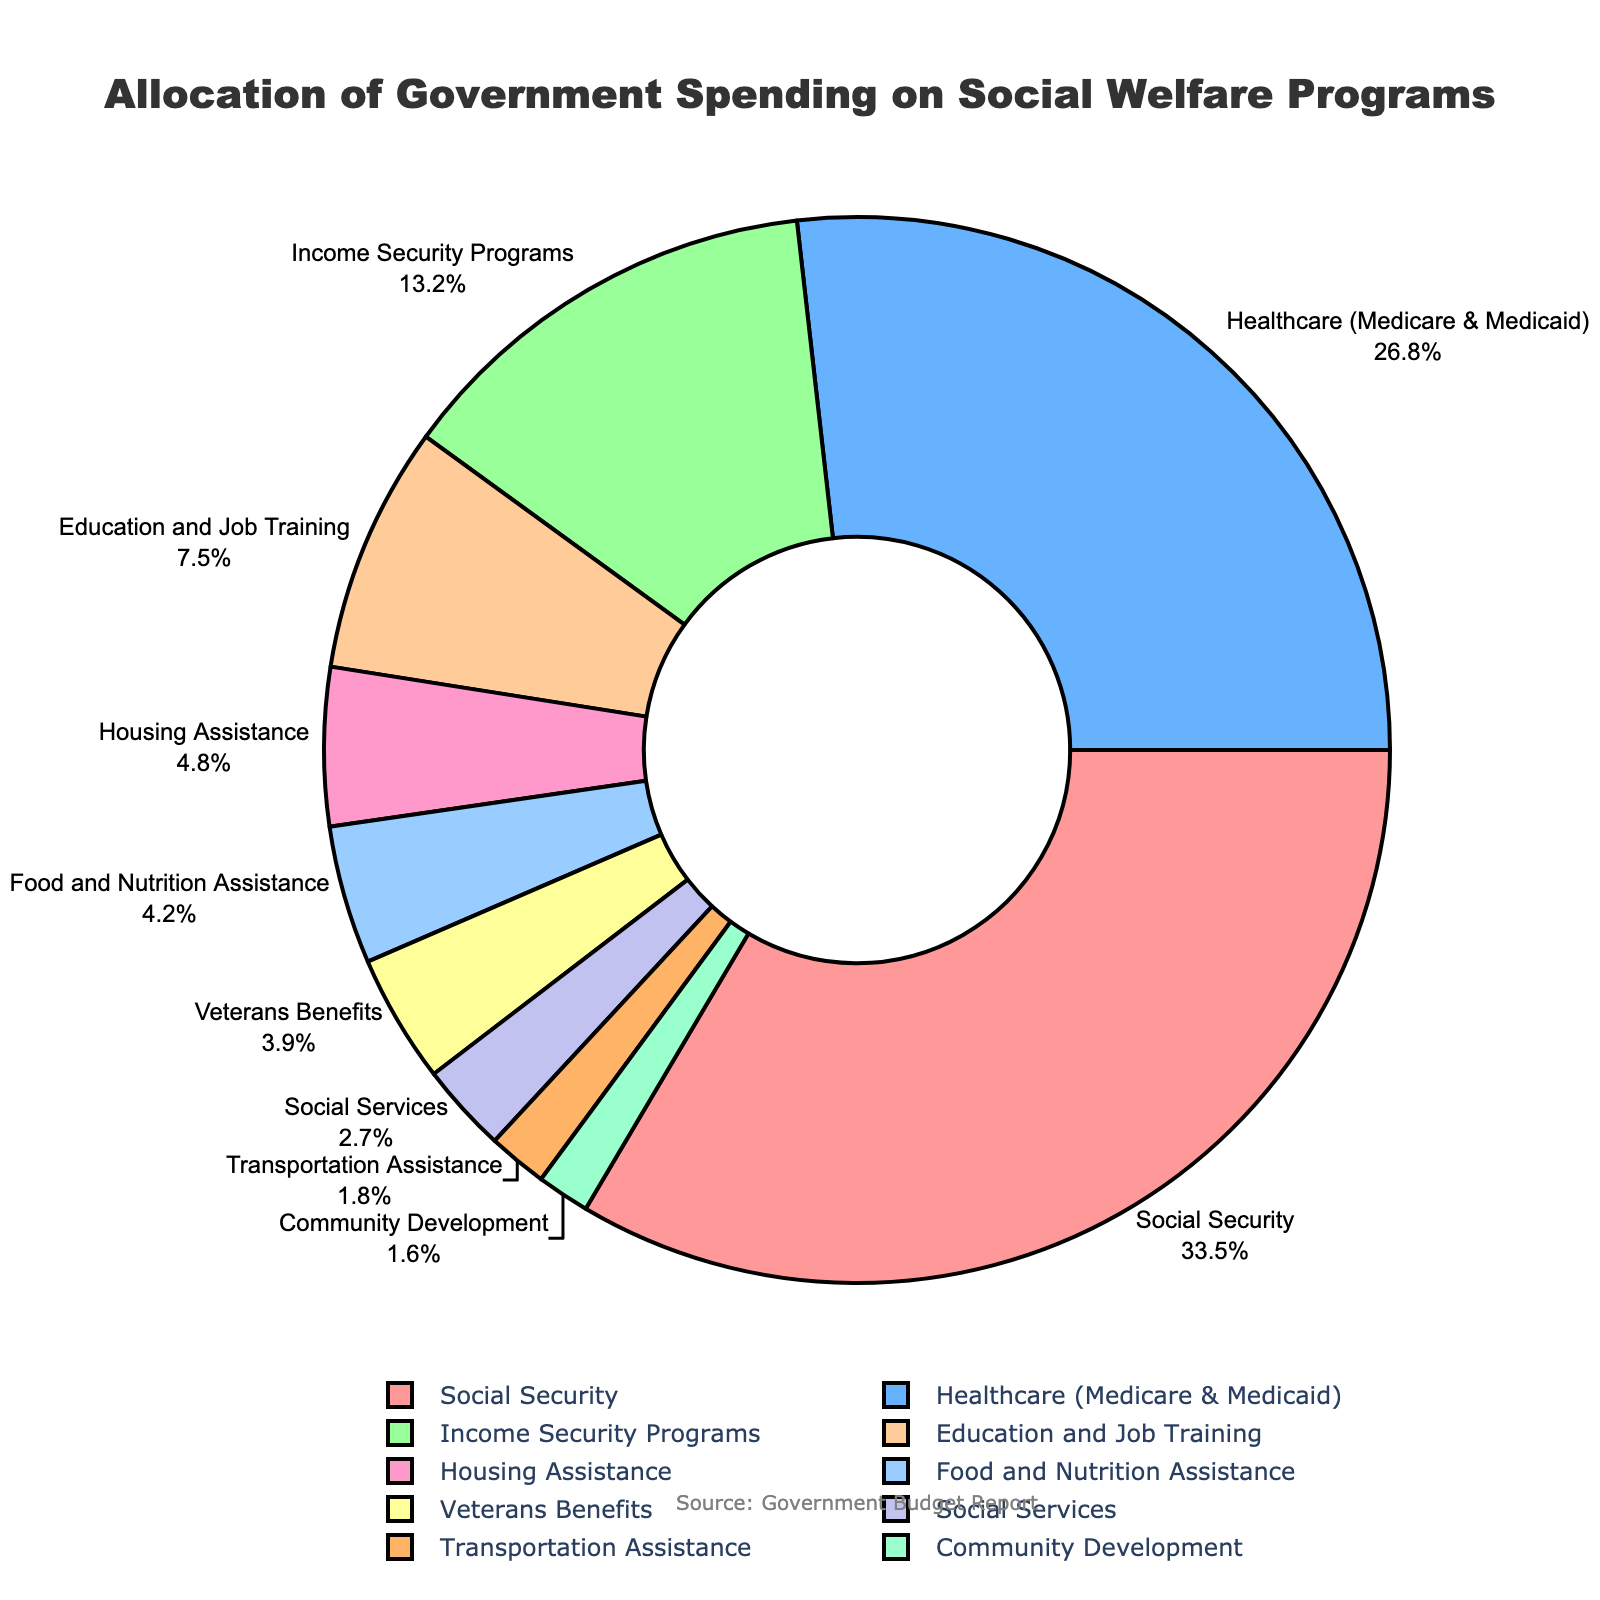What percentage of the government spending is allocated to Healthcare (Medicare & Medicaid) compared to Education and Job Training? According to the pie chart, Healthcare (Medicare & Medicaid) is allocated 26.8% and Education and Job Training is allocated 7.5%. Therefore, Healthcare receives a higher percentage of government spending compared to Education and Job Training (26.8% versus 7.5%).
Answer: 26.8% versus 7.5% What is the combined percentage of government spending on Social Security, Healthcare (Medicare & Medicaid), and Income Security Programs? To find the combined percentage, add the respective percentages: Social Security (33.5%), Healthcare (26.8%), and Income Security Programs (13.2%). The total is 33.5 + 26.8 + 13.2 = 73.5%.
Answer: 73.5% Which category has the smallest percentage allocation and how much is it? The category with the smallest percentage allocation is Community Development at 1.6%.
Answer: Community Development, 1.6% By how much does the percentage of government spending on Food and Nutrition Assistance differ from Housing Assistance? According to the pie chart, Food and Nutrition Assistance is allocated 4.2% and Housing Assistance is allocated 4.8%. The difference is 4.8 - 4.2 = 0.6%.
Answer: 0.6% Is the spending on Veterans Benefits greater or less than the combined spending on Transportation Assistance and Community Development? By how much? According to the pie chart, Veterans Benefits is allocated 3.9%, Transportation Assistance is 1.8%, and Community Development is 1.6%. Combine the latter two: 1.8 + 1.6 = 3.4%. Veterans Benefits (3.9%) is greater than the combined spending (3.4%) by 3.9 - 3.4 = 0.5%.
Answer: Greater by 0.5% What is the average percentage of spending among Veterans Benefits, Social Services, and Transportation Assistance? To find the average, add the percentages for Veterans Benefits (3.9%), Social Services (2.7%), and Transportation Assistance (1.8%), then divide by 3. The total is 3.9 + 2.7 + 1.8 = 8.4, and the average is 8.4 / 3 ≈ 2.8%.
Answer: 2.8% How many percentage points more is spent on Social Security than on Education and Job Training? According to the pie chart, Social Security is allocated 33.5% and Education and Job Training is allocated 7.5%. The difference is 33.5 - 7.5 = 26.0 percentage points.
Answer: 26.0 percentage points If an observer wants to know the total percentage of the budget allocated to Social Services, Transportation Assistance, and Community Development combined, what would it be? To find the combined percentage, sum the respective allocations: Social Services (2.7%), Transportation Assistance (1.8%), and Community Development (1.6%). The total is 2.7 + 1.8 + 1.6 = 6.1%.
Answer: 6.1% What is the visual color used for the category with the highest percentage allocation in the chart? The highest percentage allocation is for Social Security at 33.5%. According to the colors used in the chart, Social Security is represented by the color red.
Answer: Red 